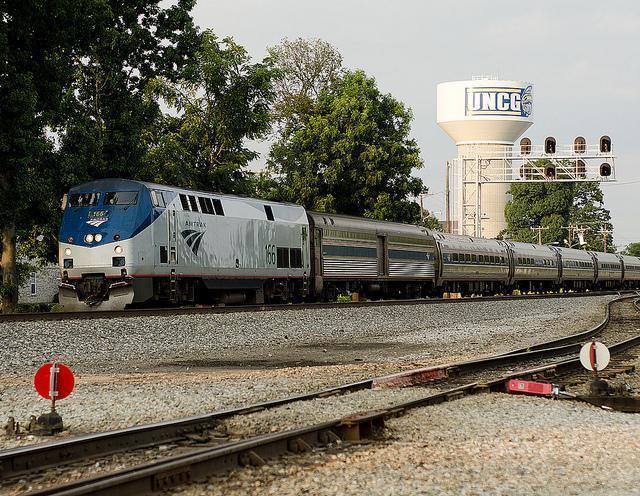How many trains are in the picture?
Give a very brief answer. 1. 